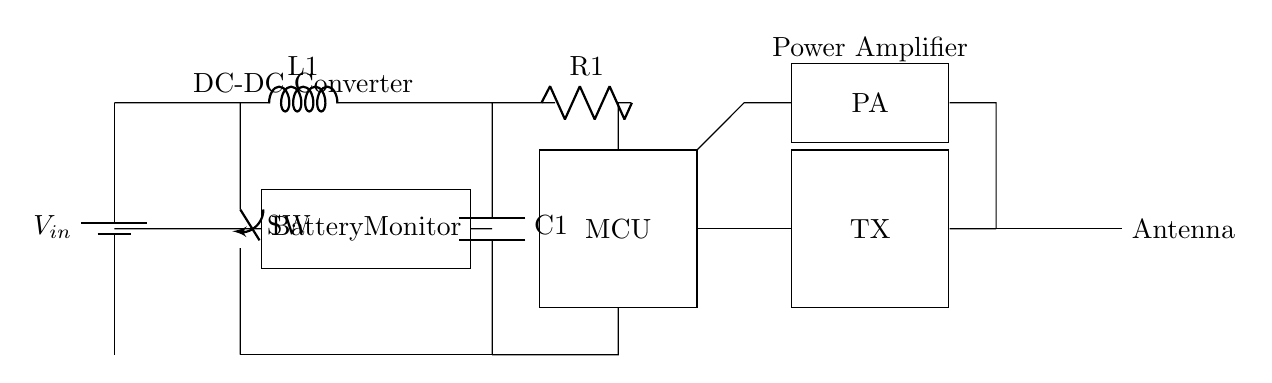What type of voltage source is used in this circuit? The circuit contains a battery symbol labeled V_in, indicating a direct current voltage source.
Answer: Battery What is the purpose of the component labeled L1? The symbol L1 represents an inductor, commonly used in power management circuits to store energy in a magnetic field and filter voltage fluctuations.
Answer: Inductor How many main components are connected to the microcontroller? The microcontroller is connected to three main components: the voltage regulator, the power amplifier, and the wireless transmitter.
Answer: Three What is the function of the power amplifier labeled PA? The power amplifier boosts the signal power before it is transmitted through the antenna, ensuring better transmission distance and quality.
Answer: Signal boost What is the role of the battery monitor in the circuit? The battery monitor is responsible for tracking the battery's voltage level and ensuring the system operates within safe limits to prevent over-discharge.
Answer: Monitoring Which component is used to regulate the output voltage in this circuit? The voltage regulator, situated after the inductor, is designed to maintain a stable output voltage despite variations in input voltage or load.
Answer: Voltage regulator What does the antenna connected at the end of the circuit do? The antenna converts the electrical signals generated by the wireless transmitter into electromagnetic waves for wireless transmission.
Answer: Transmission 